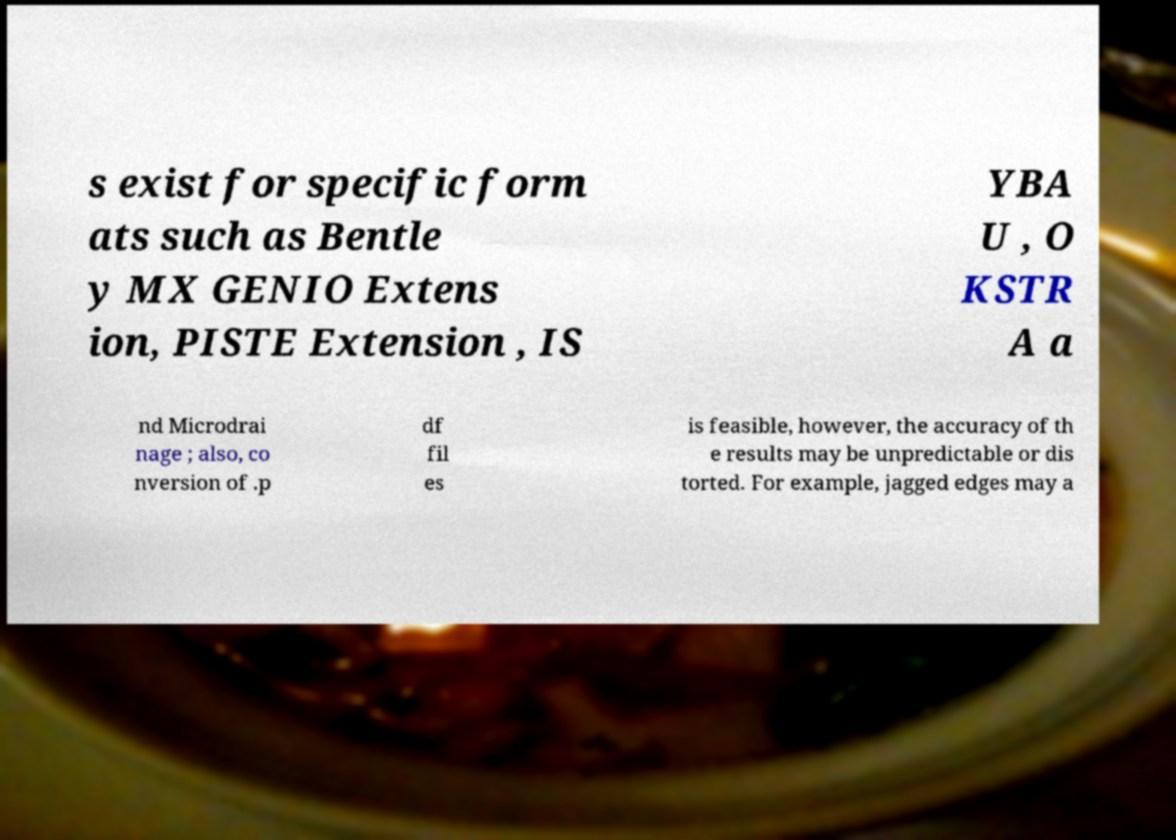I need the written content from this picture converted into text. Can you do that? s exist for specific form ats such as Bentle y MX GENIO Extens ion, PISTE Extension , IS YBA U , O KSTR A a nd Microdrai nage ; also, co nversion of .p df fil es is feasible, however, the accuracy of th e results may be unpredictable or dis torted. For example, jagged edges may a 